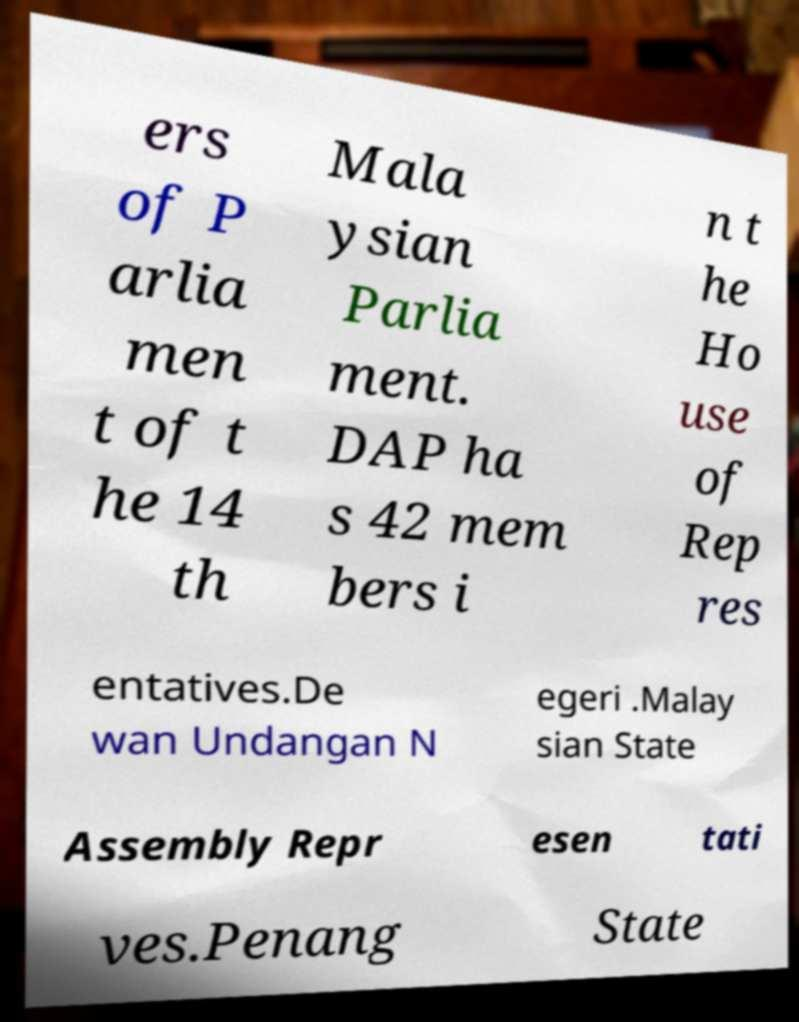Could you assist in decoding the text presented in this image and type it out clearly? ers of P arlia men t of t he 14 th Mala ysian Parlia ment. DAP ha s 42 mem bers i n t he Ho use of Rep res entatives.De wan Undangan N egeri .Malay sian State Assembly Repr esen tati ves.Penang State 